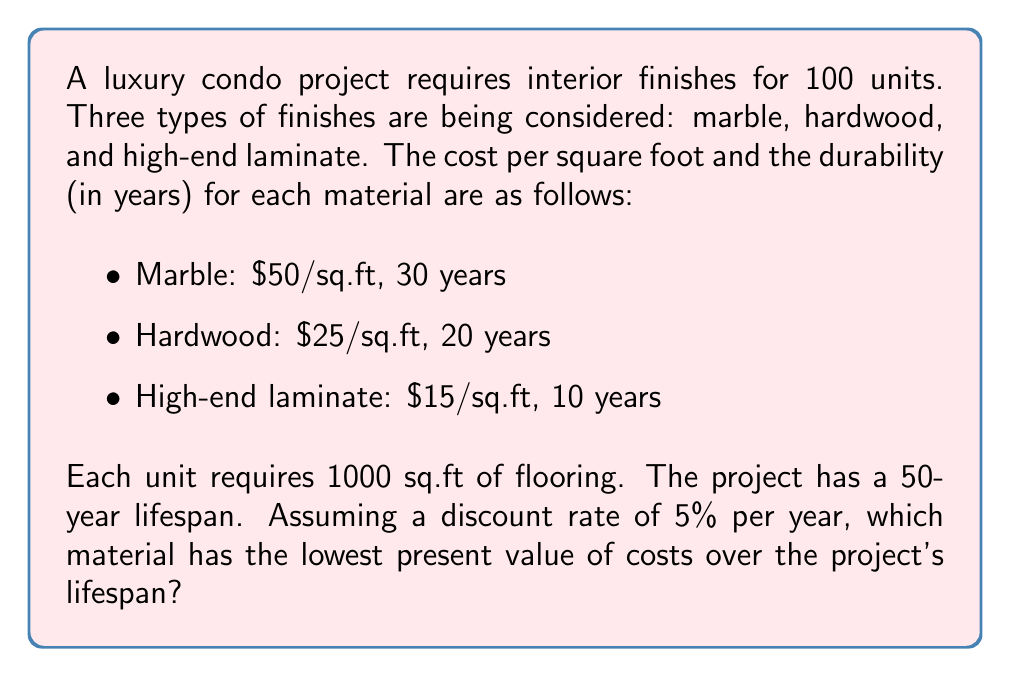Solve this math problem. To solve this problem, we need to calculate the present value of costs for each material over the 50-year project lifespan. We'll use the following steps:

1. Calculate the initial cost for each material.
2. Determine how many times each material needs to be replaced over 50 years.
3. Calculate the present value of future replacement costs.
4. Sum the initial cost and present value of replacements for each material.

Let's go through each step:

1. Initial cost for 100 units (1000 sq.ft each):
   - Marble: $50 * 1000 * 100 = $5,000,000
   - Hardwood: $25 * 1000 * 100 = $2,500,000
   - Laminate: $15 * 1000 * 100 = $1,500,000

2. Number of replacements needed:
   - Marble: 1 replacement at year 30
   - Hardwood: 2 replacements at years 20 and 40
   - Laminate: 4 replacements at years 10, 20, 30, and 40

3. Present value of future replacements:
   We'll use the present value formula: $PV = FV / (1 + r)^n$
   Where FV is the future value, r is the discount rate, and n is the number of years.

   - Marble: $PV = 5,000,000 / (1 + 0.05)^{30} = 1,151,788$
   - Hardwood: 
     $PV_1 = 2,500,000 / (1 + 0.05)^{20} = 942,041$
     $PV_2 = 2,500,000 / (1 + 0.05)^{40} = 354,478$
   - Laminate:
     $PV_1 = 1,500,000 / (1 + 0.05)^{10} = 920,592$
     $PV_2 = 1,500,000 / (1 + 0.05)^{20} = 565,225$
     $PV_3 = 1,500,000 / (1 + 0.05)^{30} = 345,536$
     $PV_4 = 1,500,000 / (1 + 0.05)^{40} = 212,687$

4. Total present value of costs:
   - Marble: $5,000,000 + 1,151,788 = 6,151,788$
   - Hardwood: $2,500,000 + 942,041 + 354,478 = 3,796,519$
   - Laminate: $1,500,000 + 920,592 + 565,225 + 345,536 + 212,687 = 3,544,040$

Therefore, the high-end laminate has the lowest present value of costs over the project's lifespan.
Answer: The high-end laminate has the lowest present value of costs at $3,544,040 over the 50-year project lifespan. 